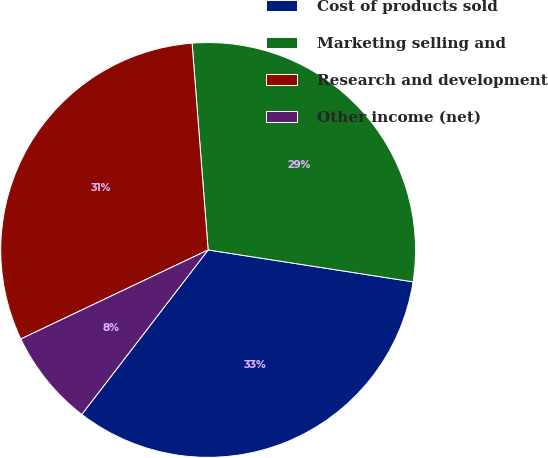Convert chart to OTSL. <chart><loc_0><loc_0><loc_500><loc_500><pie_chart><fcel>Cost of products sold<fcel>Marketing selling and<fcel>Research and development<fcel>Other income (net)<nl><fcel>32.97%<fcel>28.69%<fcel>30.83%<fcel>7.51%<nl></chart> 